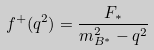Convert formula to latex. <formula><loc_0><loc_0><loc_500><loc_500>f ^ { + } ( q ^ { 2 } ) = \frac { F _ { * } } { m _ { B ^ { * } } ^ { 2 } - q ^ { 2 } }</formula> 